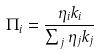<formula> <loc_0><loc_0><loc_500><loc_500>\Pi _ { i } = \frac { \eta _ { i } k _ { i } } { \sum _ { j } \eta _ { j } k _ { j } }</formula> 